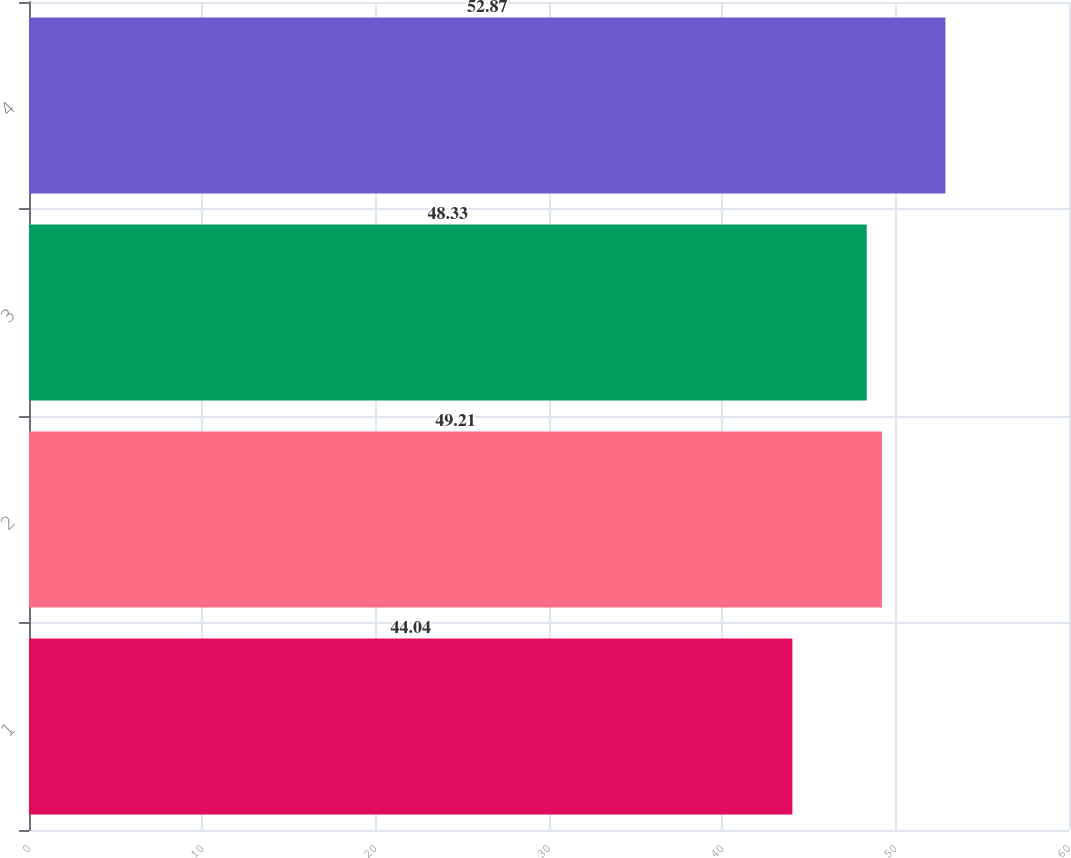Convert chart. <chart><loc_0><loc_0><loc_500><loc_500><bar_chart><fcel>1<fcel>2<fcel>3<fcel>4<nl><fcel>44.04<fcel>49.21<fcel>48.33<fcel>52.87<nl></chart> 